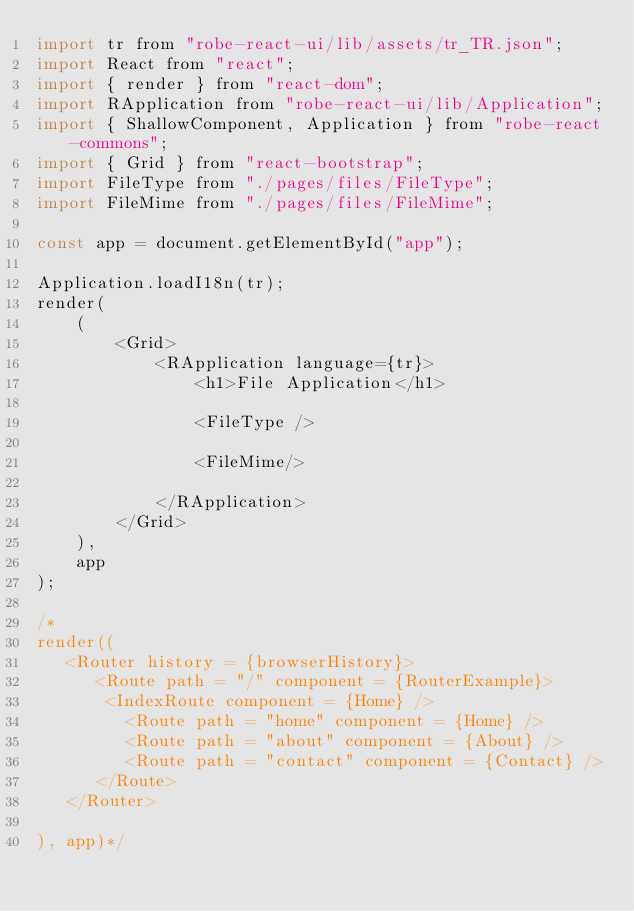Convert code to text. <code><loc_0><loc_0><loc_500><loc_500><_JavaScript_>import tr from "robe-react-ui/lib/assets/tr_TR.json";
import React from "react";
import { render } from "react-dom";
import RApplication from "robe-react-ui/lib/Application";
import { ShallowComponent, Application } from "robe-react-commons";
import { Grid } from "react-bootstrap";
import FileType from "./pages/files/FileType";
import FileMime from "./pages/files/FileMime";

const app = document.getElementById("app");

Application.loadI18n(tr);
render(
    (
        <Grid>
            <RApplication language={tr}>
                <h1>File Application</h1>
               
                <FileType />

                <FileMime/>
              
            </RApplication>
        </Grid>
    ),
    app
);

/*
render((
   <Router history = {browserHistory}>
      <Route path = "/" component = {RouterExample}>
       <IndexRoute component = {Home} />   
         <Route path = "home" component = {Home} />
         <Route path = "about" component = {About} />
         <Route path = "contact" component = {Contact} />
      </Route>
   </Router>
	
), app)*/
</code> 